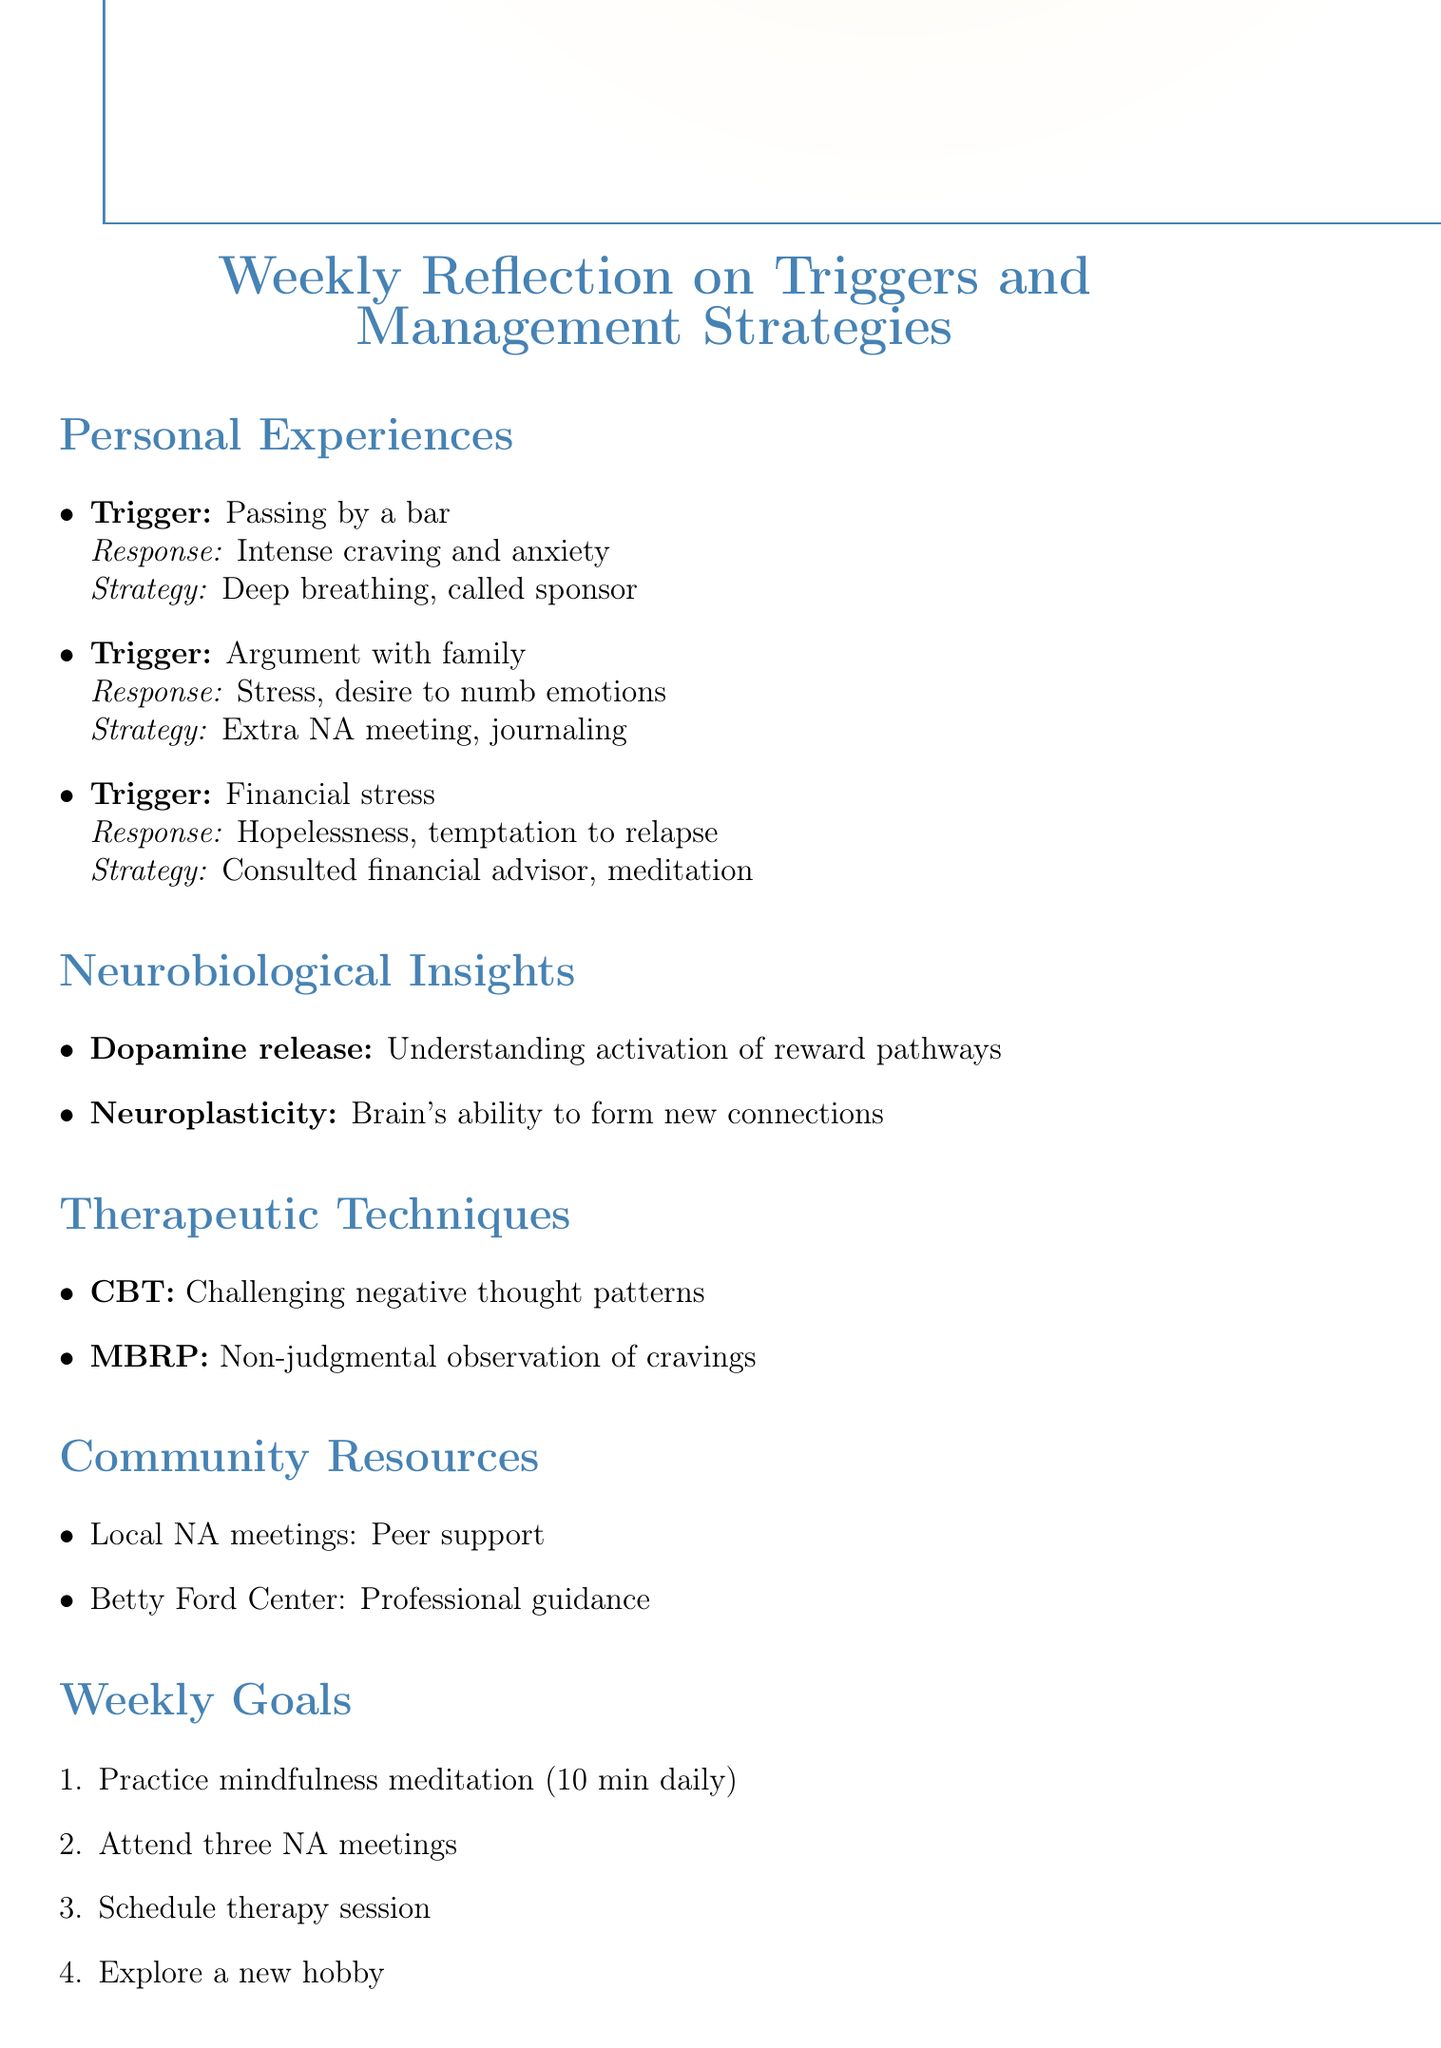What was the first trigger mentioned? The first trigger listed in the personal experiences is "Passing by a bar on my way home from work."
Answer: Passing by a bar How did the person feel after an argument with a family member? The emotional response noted after the argument was "Stress and desire to numb emotions."
Answer: Stress and desire to numb emotions What strategy was used to cope with unexpected financial stress? The management strategy employed was "Consulted with financial advisor and practiced mindfulness meditation."
Answer: Consulted with financial advisor and practiced mindfulness meditation Which therapeutic technique focuses on challenging negative thought patterns? The technique that focuses on this aspect is "Cognitive Behavioral Therapy (CBT)."
Answer: Cognitive Behavioral Therapy (CBT) How many goals are outlined for the week? The document lists a total of "four" weekly goals.
Answer: four What community resource offers peer support? The local community resource that provides peer support is "Local Narcotics Anonymous meetings."
Answer: Local Narcotics Anonymous meetings What is the relevance of understanding dopamine release in relation to addiction? The relevance mentioned is "Understanding how triggers activate these pathways helps in developing coping mechanisms."
Answer: Understanding how triggers activate these pathways helps in developing coping mechanisms Which technique is designed for non-judgmental observation of cravings? The technique that focuses on this practice is "Mindfulness-Based Relapse Prevention (MBRP)."
Answer: Mindfulness-Based Relapse Prevention (MBRP) 